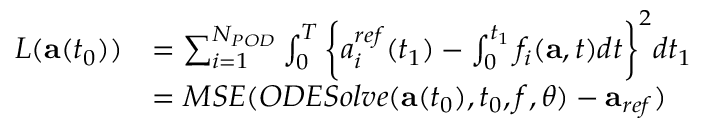Convert formula to latex. <formula><loc_0><loc_0><loc_500><loc_500>\begin{array} { r l } { L ( a ( t _ { 0 } ) ) } & { = \sum _ { i = 1 } ^ { N _ { P O D } } \int _ { 0 } ^ { T } \left \{ { a _ { i } ^ { r e f } } ( t _ { 1 } ) - \int _ { 0 } ^ { t _ { 1 } } f _ { i } ( a , t ) d t \right \} ^ { 2 } d t _ { 1 } } \\ & { = M S E ( O D E S o l v e ( a ( t _ { 0 } ) , t _ { 0 } , f , \theta ) - a _ { r e f } ) } \end{array}</formula> 